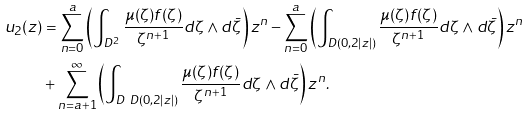Convert formula to latex. <formula><loc_0><loc_0><loc_500><loc_500>u _ { 2 } ( z ) & = \sum _ { n = 0 } ^ { a } \left ( \int _ { D ^ { 2 } } \frac { \mu ( \zeta ) f ( \zeta ) } { \zeta ^ { n + 1 } } d \zeta \wedge d \bar { \zeta } \right ) z ^ { n } - \sum _ { n = 0 } ^ { a } \left ( \int _ { D ( 0 , 2 | z | ) } \frac { \mu ( \zeta ) f ( \zeta ) } { \zeta ^ { n + 1 } } d \zeta \wedge d \bar { \zeta } \right ) z ^ { n } \\ & + \sum _ { n = a + 1 } ^ { \infty } \left ( \int _ { D \ D ( 0 , 2 | z | ) } \frac { \mu ( \zeta ) f ( \zeta ) } { \zeta ^ { n + 1 } } d \zeta \wedge d \bar { \zeta } \right ) z ^ { n } .</formula> 